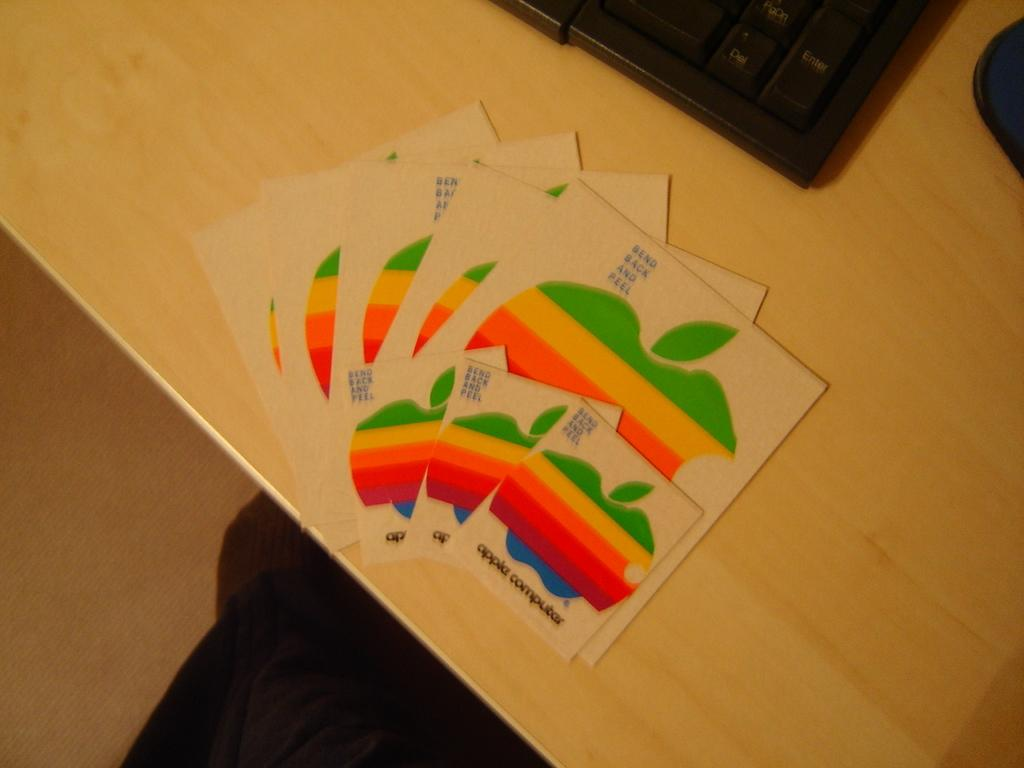What is the main object in the image? There is a table in the image. What is on the table? There are cards on the table. What other object is near the table? There is a keyboard beside the cards. Can you tell me how many clams are on the keyboard in the image? There are no clams present in the image; the keyboard is beside the cards on the table. 